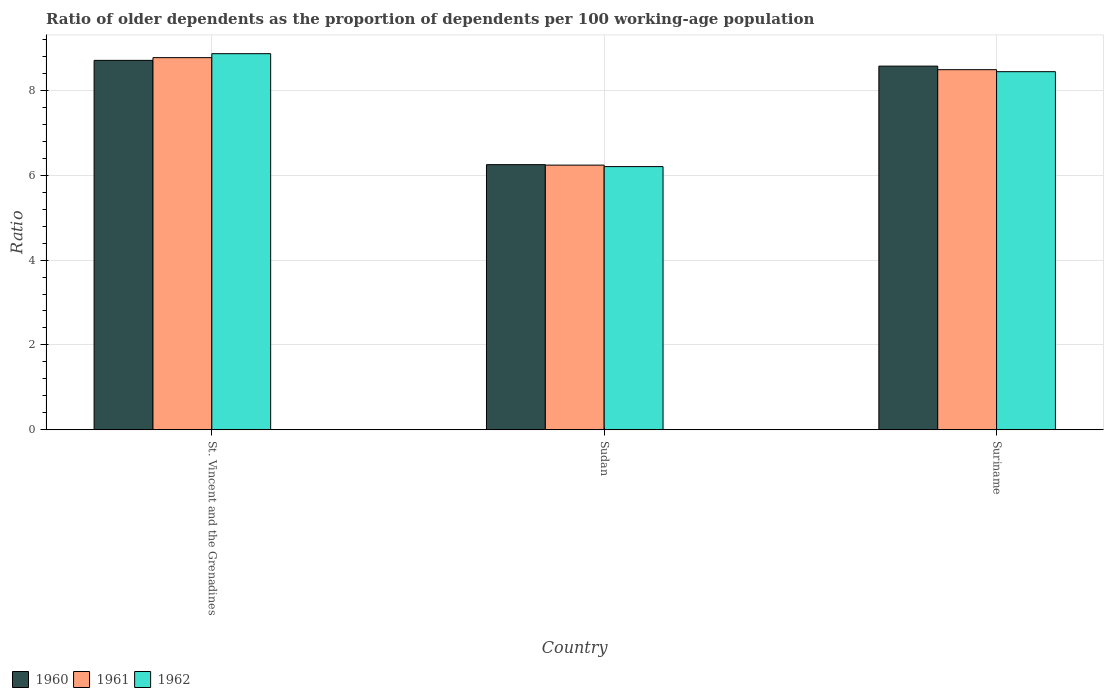How many different coloured bars are there?
Keep it short and to the point. 3. How many groups of bars are there?
Offer a terse response. 3. Are the number of bars per tick equal to the number of legend labels?
Give a very brief answer. Yes. What is the label of the 2nd group of bars from the left?
Your answer should be very brief. Sudan. What is the age dependency ratio(old) in 1961 in St. Vincent and the Grenadines?
Your answer should be compact. 8.77. Across all countries, what is the maximum age dependency ratio(old) in 1961?
Give a very brief answer. 8.77. Across all countries, what is the minimum age dependency ratio(old) in 1960?
Ensure brevity in your answer.  6.25. In which country was the age dependency ratio(old) in 1962 maximum?
Make the answer very short. St. Vincent and the Grenadines. In which country was the age dependency ratio(old) in 1962 minimum?
Keep it short and to the point. Sudan. What is the total age dependency ratio(old) in 1960 in the graph?
Keep it short and to the point. 23.53. What is the difference between the age dependency ratio(old) in 1962 in Sudan and that in Suriname?
Provide a succinct answer. -2.24. What is the difference between the age dependency ratio(old) in 1960 in St. Vincent and the Grenadines and the age dependency ratio(old) in 1961 in Suriname?
Your answer should be very brief. 0.22. What is the average age dependency ratio(old) in 1962 per country?
Make the answer very short. 7.84. What is the difference between the age dependency ratio(old) of/in 1960 and age dependency ratio(old) of/in 1961 in Suriname?
Offer a terse response. 0.08. In how many countries, is the age dependency ratio(old) in 1961 greater than 1.2000000000000002?
Give a very brief answer. 3. What is the ratio of the age dependency ratio(old) in 1962 in St. Vincent and the Grenadines to that in Sudan?
Your response must be concise. 1.43. Is the age dependency ratio(old) in 1961 in St. Vincent and the Grenadines less than that in Suriname?
Provide a succinct answer. No. Is the difference between the age dependency ratio(old) in 1960 in St. Vincent and the Grenadines and Suriname greater than the difference between the age dependency ratio(old) in 1961 in St. Vincent and the Grenadines and Suriname?
Offer a very short reply. No. What is the difference between the highest and the second highest age dependency ratio(old) in 1961?
Your response must be concise. 0.28. What is the difference between the highest and the lowest age dependency ratio(old) in 1961?
Your answer should be compact. 2.53. In how many countries, is the age dependency ratio(old) in 1962 greater than the average age dependency ratio(old) in 1962 taken over all countries?
Your answer should be very brief. 2. What does the 2nd bar from the left in Sudan represents?
Ensure brevity in your answer.  1961. Is it the case that in every country, the sum of the age dependency ratio(old) in 1960 and age dependency ratio(old) in 1961 is greater than the age dependency ratio(old) in 1962?
Give a very brief answer. Yes. How many bars are there?
Give a very brief answer. 9. How many countries are there in the graph?
Offer a very short reply. 3. Does the graph contain any zero values?
Ensure brevity in your answer.  No. Where does the legend appear in the graph?
Offer a terse response. Bottom left. What is the title of the graph?
Give a very brief answer. Ratio of older dependents as the proportion of dependents per 100 working-age population. What is the label or title of the X-axis?
Provide a succinct answer. Country. What is the label or title of the Y-axis?
Offer a terse response. Ratio. What is the Ratio in 1960 in St. Vincent and the Grenadines?
Provide a succinct answer. 8.71. What is the Ratio in 1961 in St. Vincent and the Grenadines?
Your answer should be very brief. 8.77. What is the Ratio in 1962 in St. Vincent and the Grenadines?
Your answer should be very brief. 8.86. What is the Ratio of 1960 in Sudan?
Offer a very short reply. 6.25. What is the Ratio in 1961 in Sudan?
Provide a succinct answer. 6.24. What is the Ratio of 1962 in Sudan?
Offer a very short reply. 6.2. What is the Ratio of 1960 in Suriname?
Offer a very short reply. 8.57. What is the Ratio in 1961 in Suriname?
Your answer should be very brief. 8.49. What is the Ratio of 1962 in Suriname?
Keep it short and to the point. 8.44. Across all countries, what is the maximum Ratio of 1960?
Offer a very short reply. 8.71. Across all countries, what is the maximum Ratio of 1961?
Offer a terse response. 8.77. Across all countries, what is the maximum Ratio in 1962?
Keep it short and to the point. 8.86. Across all countries, what is the minimum Ratio of 1960?
Make the answer very short. 6.25. Across all countries, what is the minimum Ratio of 1961?
Offer a very short reply. 6.24. Across all countries, what is the minimum Ratio in 1962?
Provide a short and direct response. 6.2. What is the total Ratio of 1960 in the graph?
Your response must be concise. 23.53. What is the total Ratio in 1961 in the graph?
Give a very brief answer. 23.5. What is the total Ratio in 1962 in the graph?
Keep it short and to the point. 23.51. What is the difference between the Ratio in 1960 in St. Vincent and the Grenadines and that in Sudan?
Make the answer very short. 2.46. What is the difference between the Ratio of 1961 in St. Vincent and the Grenadines and that in Sudan?
Your answer should be compact. 2.53. What is the difference between the Ratio in 1962 in St. Vincent and the Grenadines and that in Sudan?
Provide a short and direct response. 2.66. What is the difference between the Ratio in 1960 in St. Vincent and the Grenadines and that in Suriname?
Make the answer very short. 0.14. What is the difference between the Ratio of 1961 in St. Vincent and the Grenadines and that in Suriname?
Your response must be concise. 0.28. What is the difference between the Ratio of 1962 in St. Vincent and the Grenadines and that in Suriname?
Your response must be concise. 0.42. What is the difference between the Ratio of 1960 in Sudan and that in Suriname?
Your answer should be compact. -2.32. What is the difference between the Ratio of 1961 in Sudan and that in Suriname?
Provide a short and direct response. -2.25. What is the difference between the Ratio in 1962 in Sudan and that in Suriname?
Give a very brief answer. -2.24. What is the difference between the Ratio in 1960 in St. Vincent and the Grenadines and the Ratio in 1961 in Sudan?
Ensure brevity in your answer.  2.47. What is the difference between the Ratio of 1960 in St. Vincent and the Grenadines and the Ratio of 1962 in Sudan?
Offer a terse response. 2.5. What is the difference between the Ratio of 1961 in St. Vincent and the Grenadines and the Ratio of 1962 in Sudan?
Provide a short and direct response. 2.57. What is the difference between the Ratio of 1960 in St. Vincent and the Grenadines and the Ratio of 1961 in Suriname?
Give a very brief answer. 0.22. What is the difference between the Ratio of 1960 in St. Vincent and the Grenadines and the Ratio of 1962 in Suriname?
Make the answer very short. 0.27. What is the difference between the Ratio of 1961 in St. Vincent and the Grenadines and the Ratio of 1962 in Suriname?
Ensure brevity in your answer.  0.33. What is the difference between the Ratio in 1960 in Sudan and the Ratio in 1961 in Suriname?
Give a very brief answer. -2.24. What is the difference between the Ratio of 1960 in Sudan and the Ratio of 1962 in Suriname?
Your response must be concise. -2.19. What is the difference between the Ratio of 1961 in Sudan and the Ratio of 1962 in Suriname?
Offer a very short reply. -2.2. What is the average Ratio of 1960 per country?
Ensure brevity in your answer.  7.84. What is the average Ratio in 1961 per country?
Give a very brief answer. 7.83. What is the average Ratio in 1962 per country?
Your response must be concise. 7.84. What is the difference between the Ratio in 1960 and Ratio in 1961 in St. Vincent and the Grenadines?
Provide a short and direct response. -0.06. What is the difference between the Ratio in 1960 and Ratio in 1962 in St. Vincent and the Grenadines?
Provide a short and direct response. -0.16. What is the difference between the Ratio in 1961 and Ratio in 1962 in St. Vincent and the Grenadines?
Your answer should be compact. -0.09. What is the difference between the Ratio in 1960 and Ratio in 1961 in Sudan?
Give a very brief answer. 0.01. What is the difference between the Ratio of 1960 and Ratio of 1962 in Sudan?
Ensure brevity in your answer.  0.05. What is the difference between the Ratio of 1961 and Ratio of 1962 in Sudan?
Provide a succinct answer. 0.04. What is the difference between the Ratio in 1960 and Ratio in 1961 in Suriname?
Offer a very short reply. 0.08. What is the difference between the Ratio in 1960 and Ratio in 1962 in Suriname?
Your answer should be very brief. 0.13. What is the difference between the Ratio in 1961 and Ratio in 1962 in Suriname?
Make the answer very short. 0.05. What is the ratio of the Ratio in 1960 in St. Vincent and the Grenadines to that in Sudan?
Your response must be concise. 1.39. What is the ratio of the Ratio of 1961 in St. Vincent and the Grenadines to that in Sudan?
Your answer should be very brief. 1.41. What is the ratio of the Ratio in 1962 in St. Vincent and the Grenadines to that in Sudan?
Provide a short and direct response. 1.43. What is the ratio of the Ratio in 1960 in St. Vincent and the Grenadines to that in Suriname?
Give a very brief answer. 1.02. What is the ratio of the Ratio of 1961 in St. Vincent and the Grenadines to that in Suriname?
Your answer should be compact. 1.03. What is the ratio of the Ratio in 1962 in St. Vincent and the Grenadines to that in Suriname?
Your answer should be very brief. 1.05. What is the ratio of the Ratio in 1960 in Sudan to that in Suriname?
Your answer should be compact. 0.73. What is the ratio of the Ratio in 1961 in Sudan to that in Suriname?
Ensure brevity in your answer.  0.73. What is the ratio of the Ratio in 1962 in Sudan to that in Suriname?
Your response must be concise. 0.73. What is the difference between the highest and the second highest Ratio in 1960?
Give a very brief answer. 0.14. What is the difference between the highest and the second highest Ratio in 1961?
Your answer should be compact. 0.28. What is the difference between the highest and the second highest Ratio in 1962?
Make the answer very short. 0.42. What is the difference between the highest and the lowest Ratio in 1960?
Give a very brief answer. 2.46. What is the difference between the highest and the lowest Ratio in 1961?
Provide a succinct answer. 2.53. What is the difference between the highest and the lowest Ratio in 1962?
Offer a terse response. 2.66. 